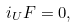<formula> <loc_0><loc_0><loc_500><loc_500>i _ { U } F = 0 ,</formula> 